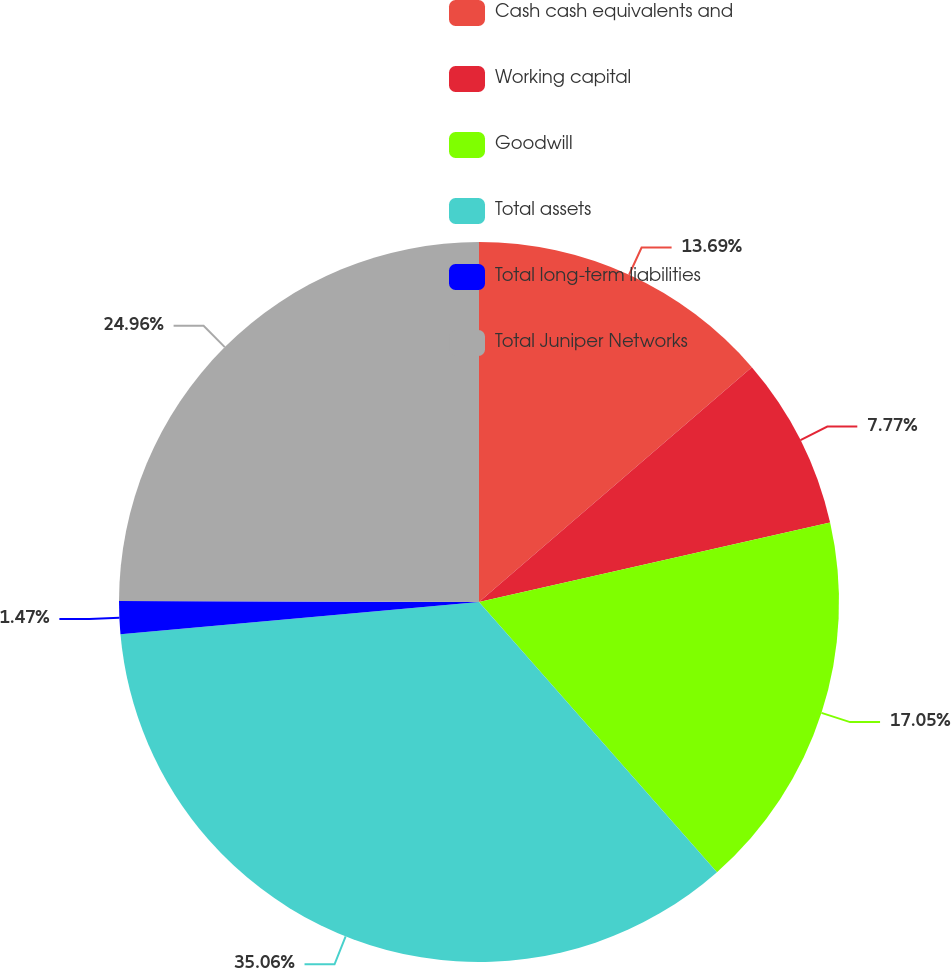Convert chart. <chart><loc_0><loc_0><loc_500><loc_500><pie_chart><fcel>Cash cash equivalents and<fcel>Working capital<fcel>Goodwill<fcel>Total assets<fcel>Total long-term liabilities<fcel>Total Juniper Networks<nl><fcel>13.69%<fcel>7.77%<fcel>17.05%<fcel>35.07%<fcel>1.47%<fcel>24.96%<nl></chart> 